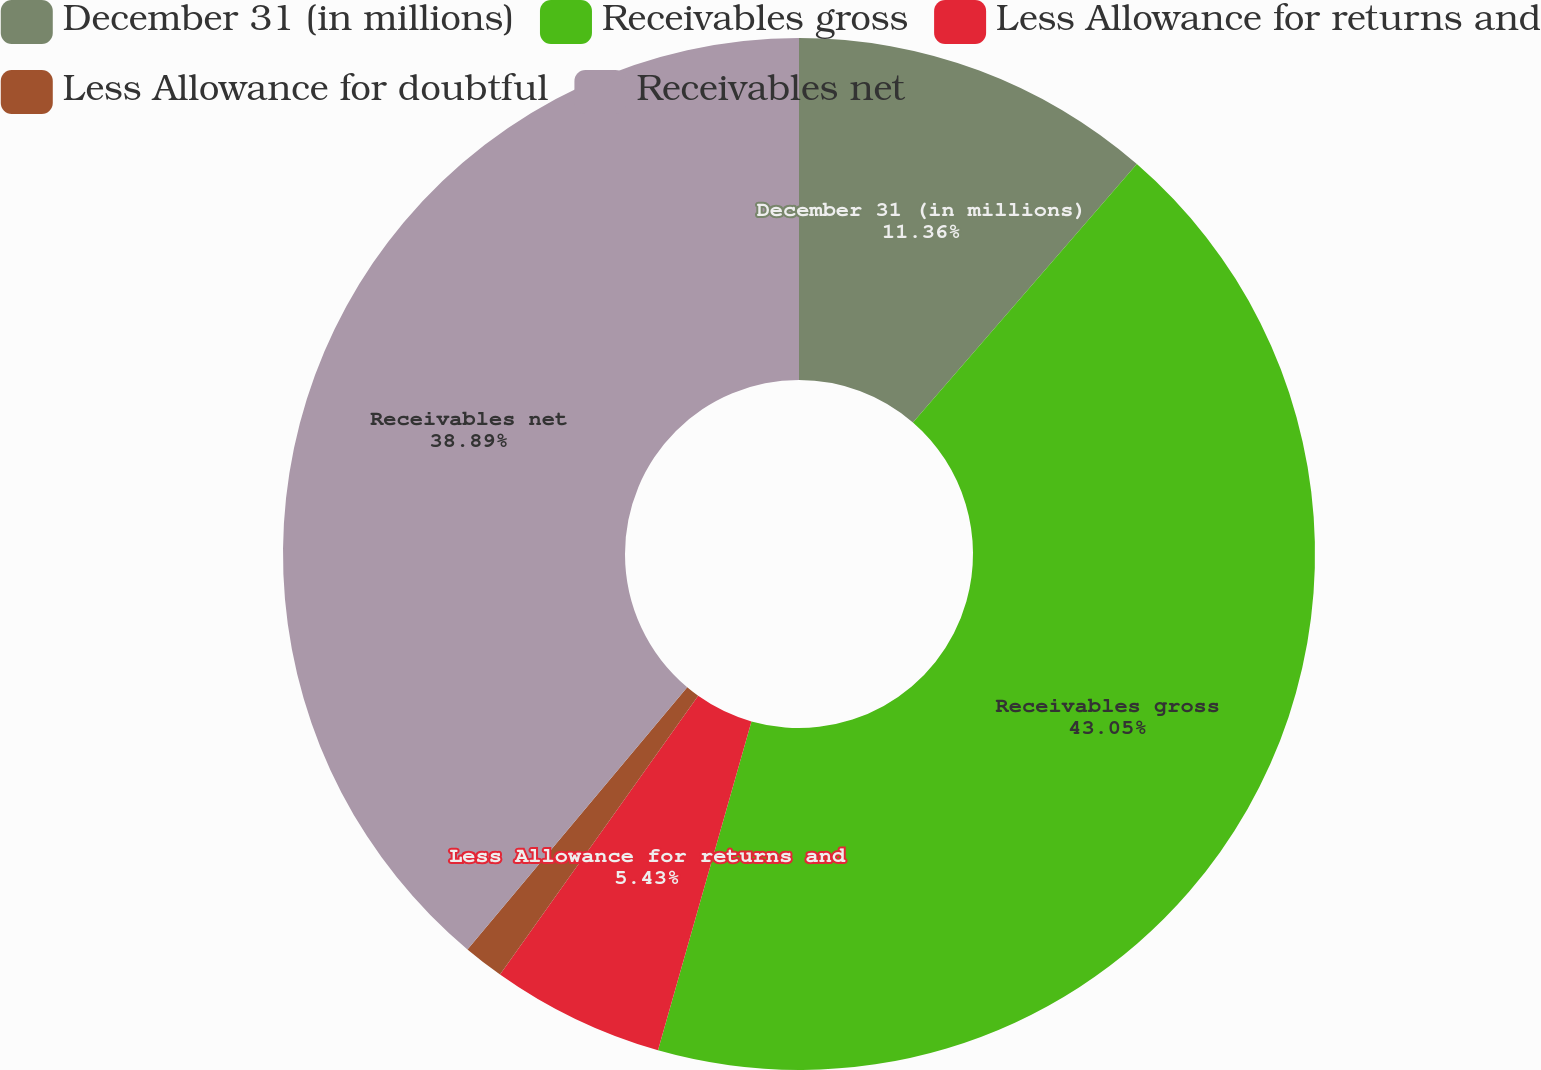Convert chart. <chart><loc_0><loc_0><loc_500><loc_500><pie_chart><fcel>December 31 (in millions)<fcel>Receivables gross<fcel>Less Allowance for returns and<fcel>Less Allowance for doubtful<fcel>Receivables net<nl><fcel>11.36%<fcel>43.04%<fcel>5.43%<fcel>1.27%<fcel>38.89%<nl></chart> 